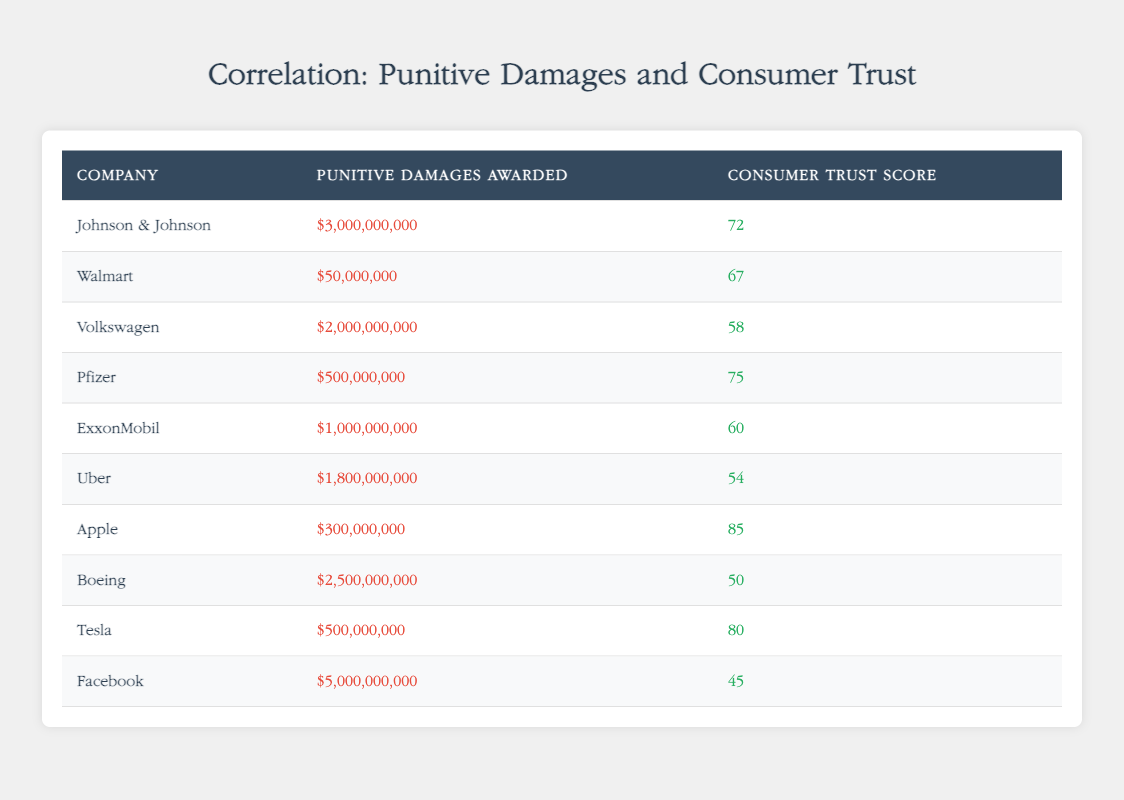What is the highest consumer trust score among the companies listed? Looking through the "Consumer Trust Score" column, the highest value is 85, which corresponds to Apple.
Answer: 85 Which company has the lowest punitive damages awarded? In the "Punitive Damages Awarded" column, the lowest value is $50,000,000, which is awarded to Walmart.
Answer: $50,000,000 What is the average punitive damages awarded for the companies listed in the table? To find the average, sum all punitive damages: 3000000000 + 50000000 + 2000000000 + 500000000 + 1000000000 + 1800000000 + 300000000 + 2500000000 + 500000000 + 5000000000 = 15750000000. There are 10 companies, so the average is 15750000000 / 10 = 1575000000.
Answer: $1,575,000,000 Is the consumer trust score for Boeing higher than that for Volkswagen? Boeing has a consumer trust score of 50 and Volkswagen has a score of 58. Since 50 is not greater than 58, the statement is false.
Answer: No Which company has a punitive damages awarded amount that is more than $1 billion and a consumer trust score below 60? Looking through the table, Boeing has $2,500,000,000 in punitive damages and a trust score of 50, which fits the criteria. Volkswagen also has more than $1 billion but a score above 58, hence the only company that meets both criteria is Boeing.
Answer: Boeing What is the difference in consumer trust scores between Apple and Facebook? The consumer trust score for Apple is 85, and for Facebook, it is 45. The difference is calculated as 85 - 45 = 40.
Answer: 40 Are companies with higher punitive damages awarded generally associated with lower consumer trust scores? Examining the data, as companies such as Johnson & Johnson and Facebook have very high punitive damages awarded but relatively low consumer trust scores, while companies like Apple have low punitive damages and high trust scores. Thus, there is a mixed correlation, but many high-damages companies indeed hold lower trust scores.
Answer: Yes (mostly correlated) Which two companies have punitive damages awarded over $2 billion? From the table, the companies with punitive damages over $2 billion are Johnson & Johnson ($3,000,000,000) and Volkswagen ($2,000,000,000).
Answer: Johnson & Johnson, Volkswagen What is the sum of consumer trust scores for companies listed in the table? Adding the trust scores: 72 + 67 + 58 + 75 + 60 + 54 + 85 + 50 + 80 + 45 = 696.
Answer: 696 